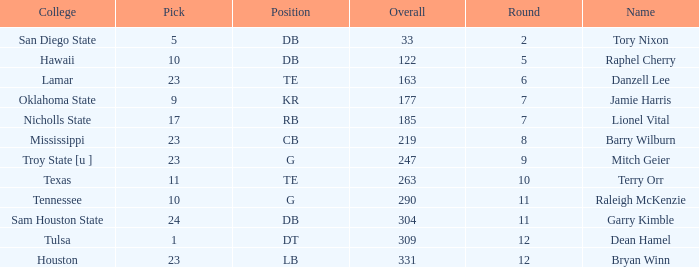Which Overall is the highest one that has a Name of raleigh mckenzie, and a Pick larger than 10? None. 